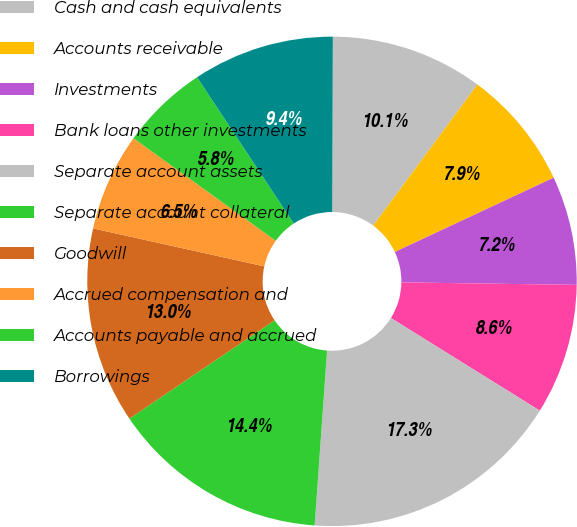Convert chart to OTSL. <chart><loc_0><loc_0><loc_500><loc_500><pie_chart><fcel>Cash and cash equivalents<fcel>Accounts receivable<fcel>Investments<fcel>Bank loans other investments<fcel>Separate account assets<fcel>Separate account collateral<fcel>Goodwill<fcel>Accrued compensation and<fcel>Accounts payable and accrued<fcel>Borrowings<nl><fcel>10.07%<fcel>7.91%<fcel>7.19%<fcel>8.63%<fcel>17.27%<fcel>14.39%<fcel>12.95%<fcel>6.47%<fcel>5.76%<fcel>9.35%<nl></chart> 